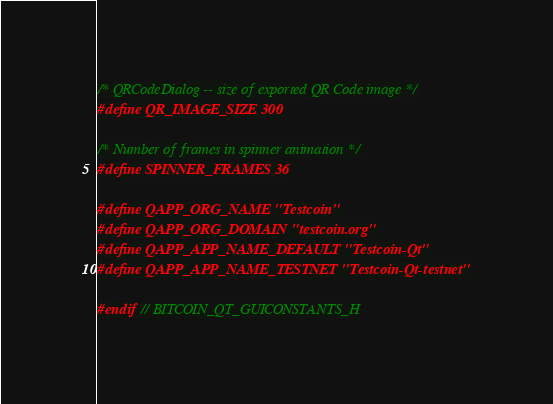Convert code to text. <code><loc_0><loc_0><loc_500><loc_500><_C_>/* QRCodeDialog -- size of exported QR Code image */
#define QR_IMAGE_SIZE 300

/* Number of frames in spinner animation */
#define SPINNER_FRAMES 36

#define QAPP_ORG_NAME "Testcoin"
#define QAPP_ORG_DOMAIN "testcoin.org"
#define QAPP_APP_NAME_DEFAULT "Testcoin-Qt"
#define QAPP_APP_NAME_TESTNET "Testcoin-Qt-testnet"

#endif // BITCOIN_QT_GUICONSTANTS_H
</code> 